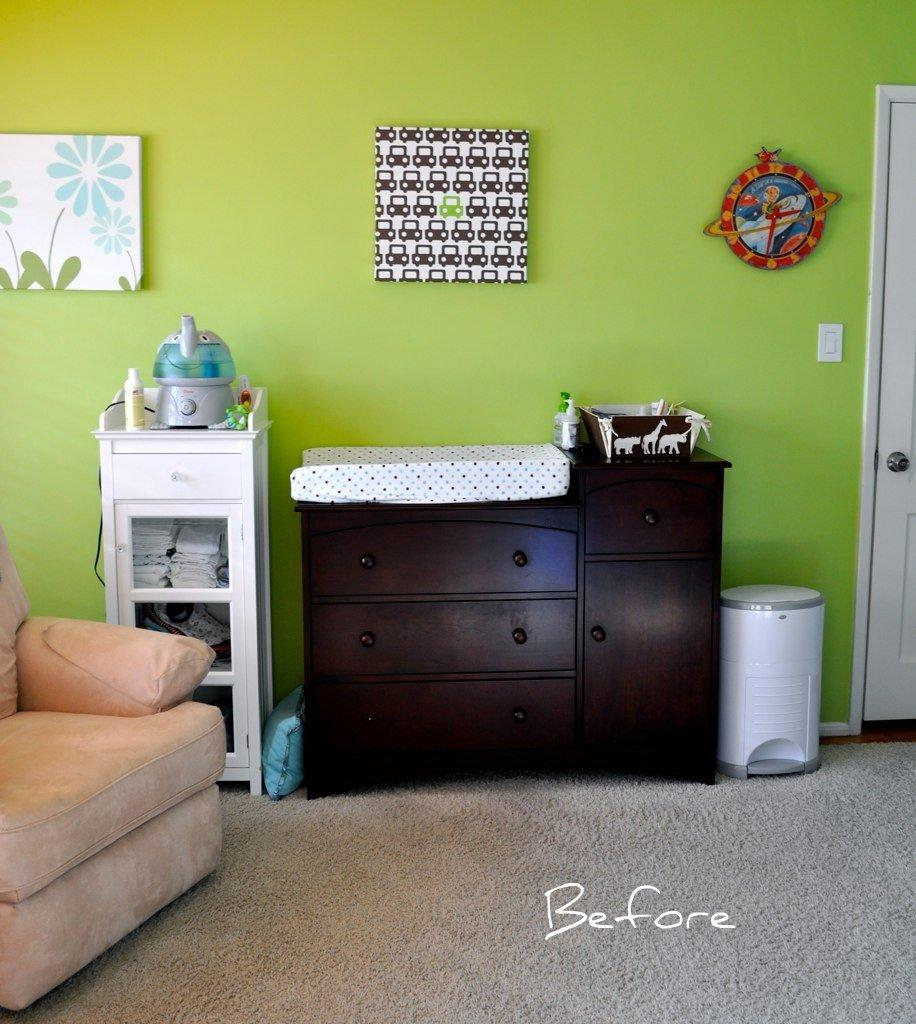<image>
Offer a succinct explanation of the picture presented. A Before picture of a room wht a green wall and a changing table. 